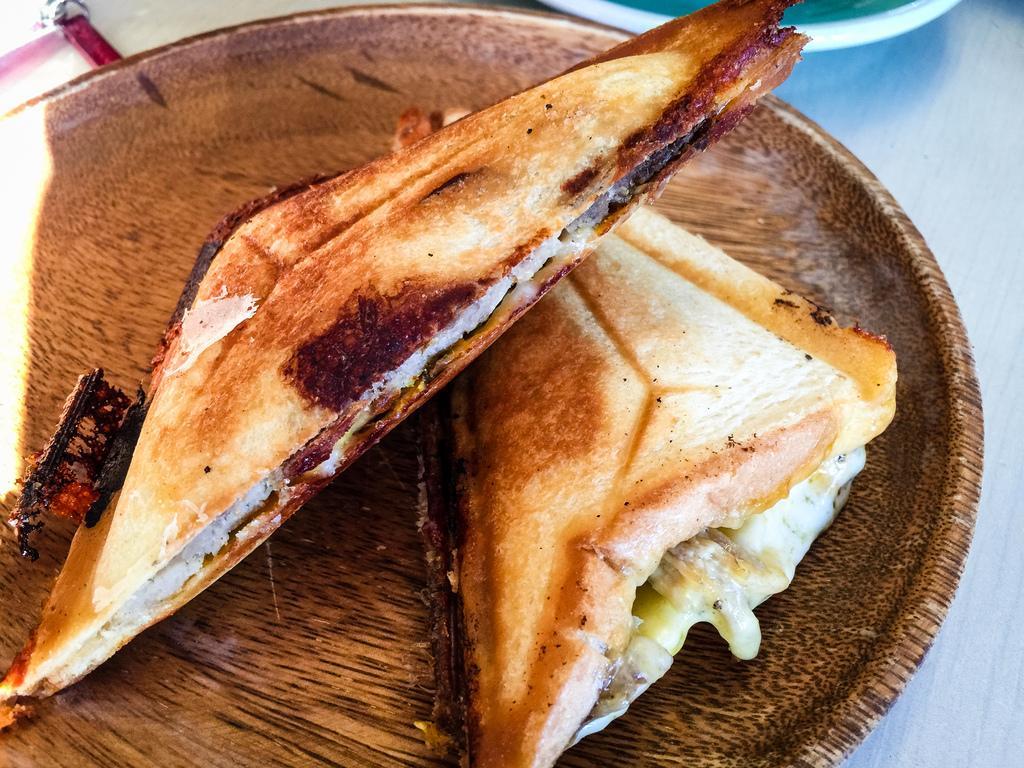Could you give a brief overview of what you see in this image? In this image there is a table and we can see plates and sandwiches placed on the table. 